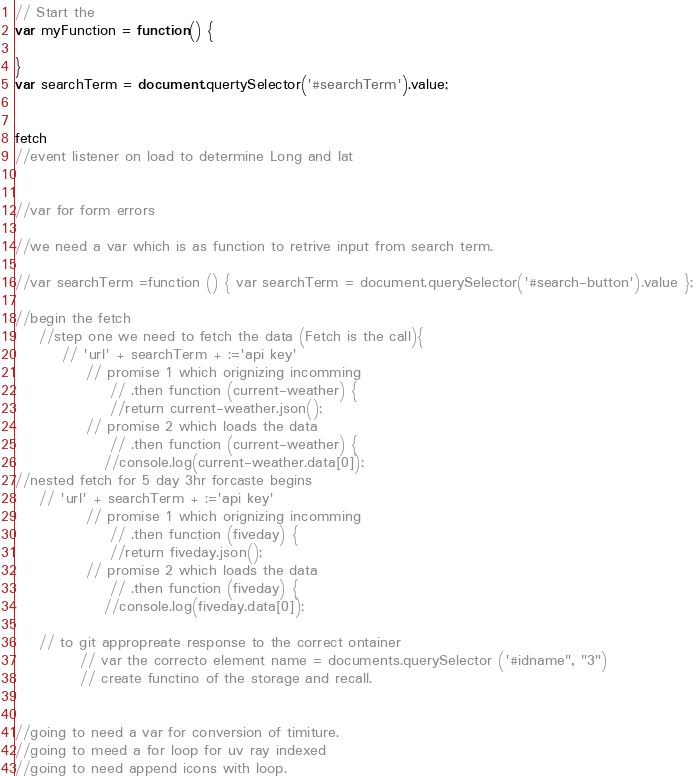Convert code to text. <code><loc_0><loc_0><loc_500><loc_500><_JavaScript_>
// Start the  
var myFunction = function() {

}
var searchTerm = document.quertySelector('#searchTerm').value;


fetch
//event listener on load to determine Long and lat


//var for form errors

//we need a var which is as function to retrive input from search term.

//var searchTerm =function () { var searchTerm = document.querySelector('#search-button').value };

//begin the fetch
    //step one we need to fetch the data (Fetch is the call){ 
        // 'url' + searchTerm + :='api key'
            // promise 1 which orignizing incomming
                // .then function (current-weather) {
                //return current-weather.json(); 
            // promise 2 which loads the data
                // .then function (current-weather) {
               //console.log(current-weather.data[0]); 
//nested fetch for 5 day 3hr forcaste begins
    // 'url' + searchTerm + :='api key'
            // promise 1 which orignizing incomming
                // .then function (fiveday) {
                //return fiveday.json(); 
            // promise 2 which loads the data
                // .then function (fiveday) {
               //console.log(fiveday.data[0]);

    // to git appropreate response to the correct ontainer 
           // var the correcto element name = documents.querySelector ('#idname", "3")
           // create functino of the storage and recall. 
    

//going to need a var for conversion of timiture.
//going to meed a for loop for uv ray indexed 
//going to need append icons with loop. </code> 